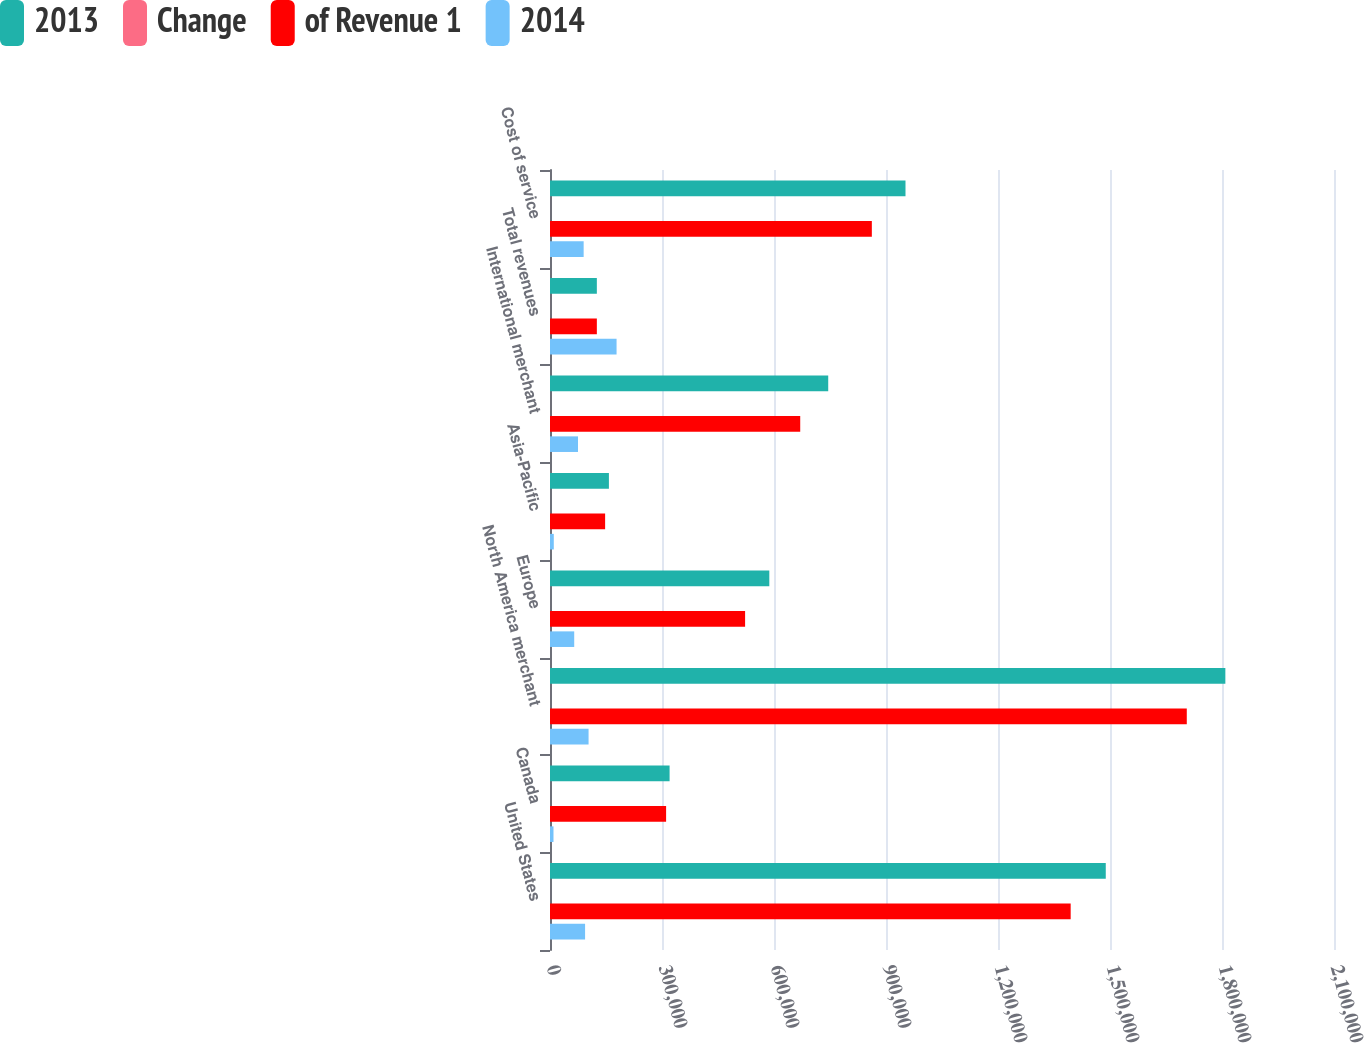Convert chart. <chart><loc_0><loc_0><loc_500><loc_500><stacked_bar_chart><ecel><fcel>United States<fcel>Canada<fcel>North America merchant<fcel>Europe<fcel>Asia-Pacific<fcel>International merchant<fcel>Total revenues<fcel>Cost of service<nl><fcel>2013<fcel>1.48866e+06<fcel>320333<fcel>1.80899e+06<fcel>587463<fcel>157781<fcel>745244<fcel>125486<fcel>952225<nl><fcel>Change<fcel>58.3<fcel>12.5<fcel>70.8<fcel>23<fcel>6.2<fcel>29.2<fcel>100<fcel>37.3<nl><fcel>of Revenue 1<fcel>1.39468e+06<fcel>311000<fcel>1.70568e+06<fcel>522593<fcel>147655<fcel>670248<fcel>125486<fcel>862075<nl><fcel>2014<fcel>93984<fcel>9333<fcel>103317<fcel>64870<fcel>10126<fcel>74996<fcel>178313<fcel>90150<nl></chart> 